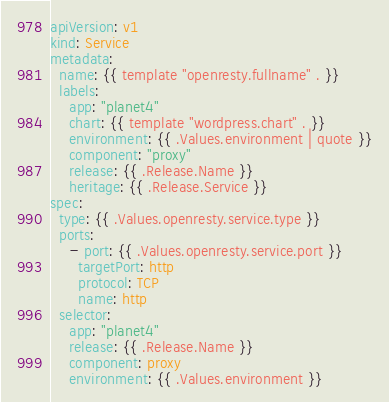<code> <loc_0><loc_0><loc_500><loc_500><_YAML_>apiVersion: v1
kind: Service
metadata:
  name: {{ template "openresty.fullname" . }}
  labels:
    app: "planet4"
    chart: {{ template "wordpress.chart" . }}
    environment: {{ .Values.environment | quote }}
    component: "proxy"
    release: {{ .Release.Name }}
    heritage: {{ .Release.Service }}
spec:
  type: {{ .Values.openresty.service.type }}
  ports:
    - port: {{ .Values.openresty.service.port }}
      targetPort: http
      protocol: TCP
      name: http
  selector:
    app: "planet4"
    release: {{ .Release.Name }}
    component: proxy
    environment: {{ .Values.environment }}
</code> 